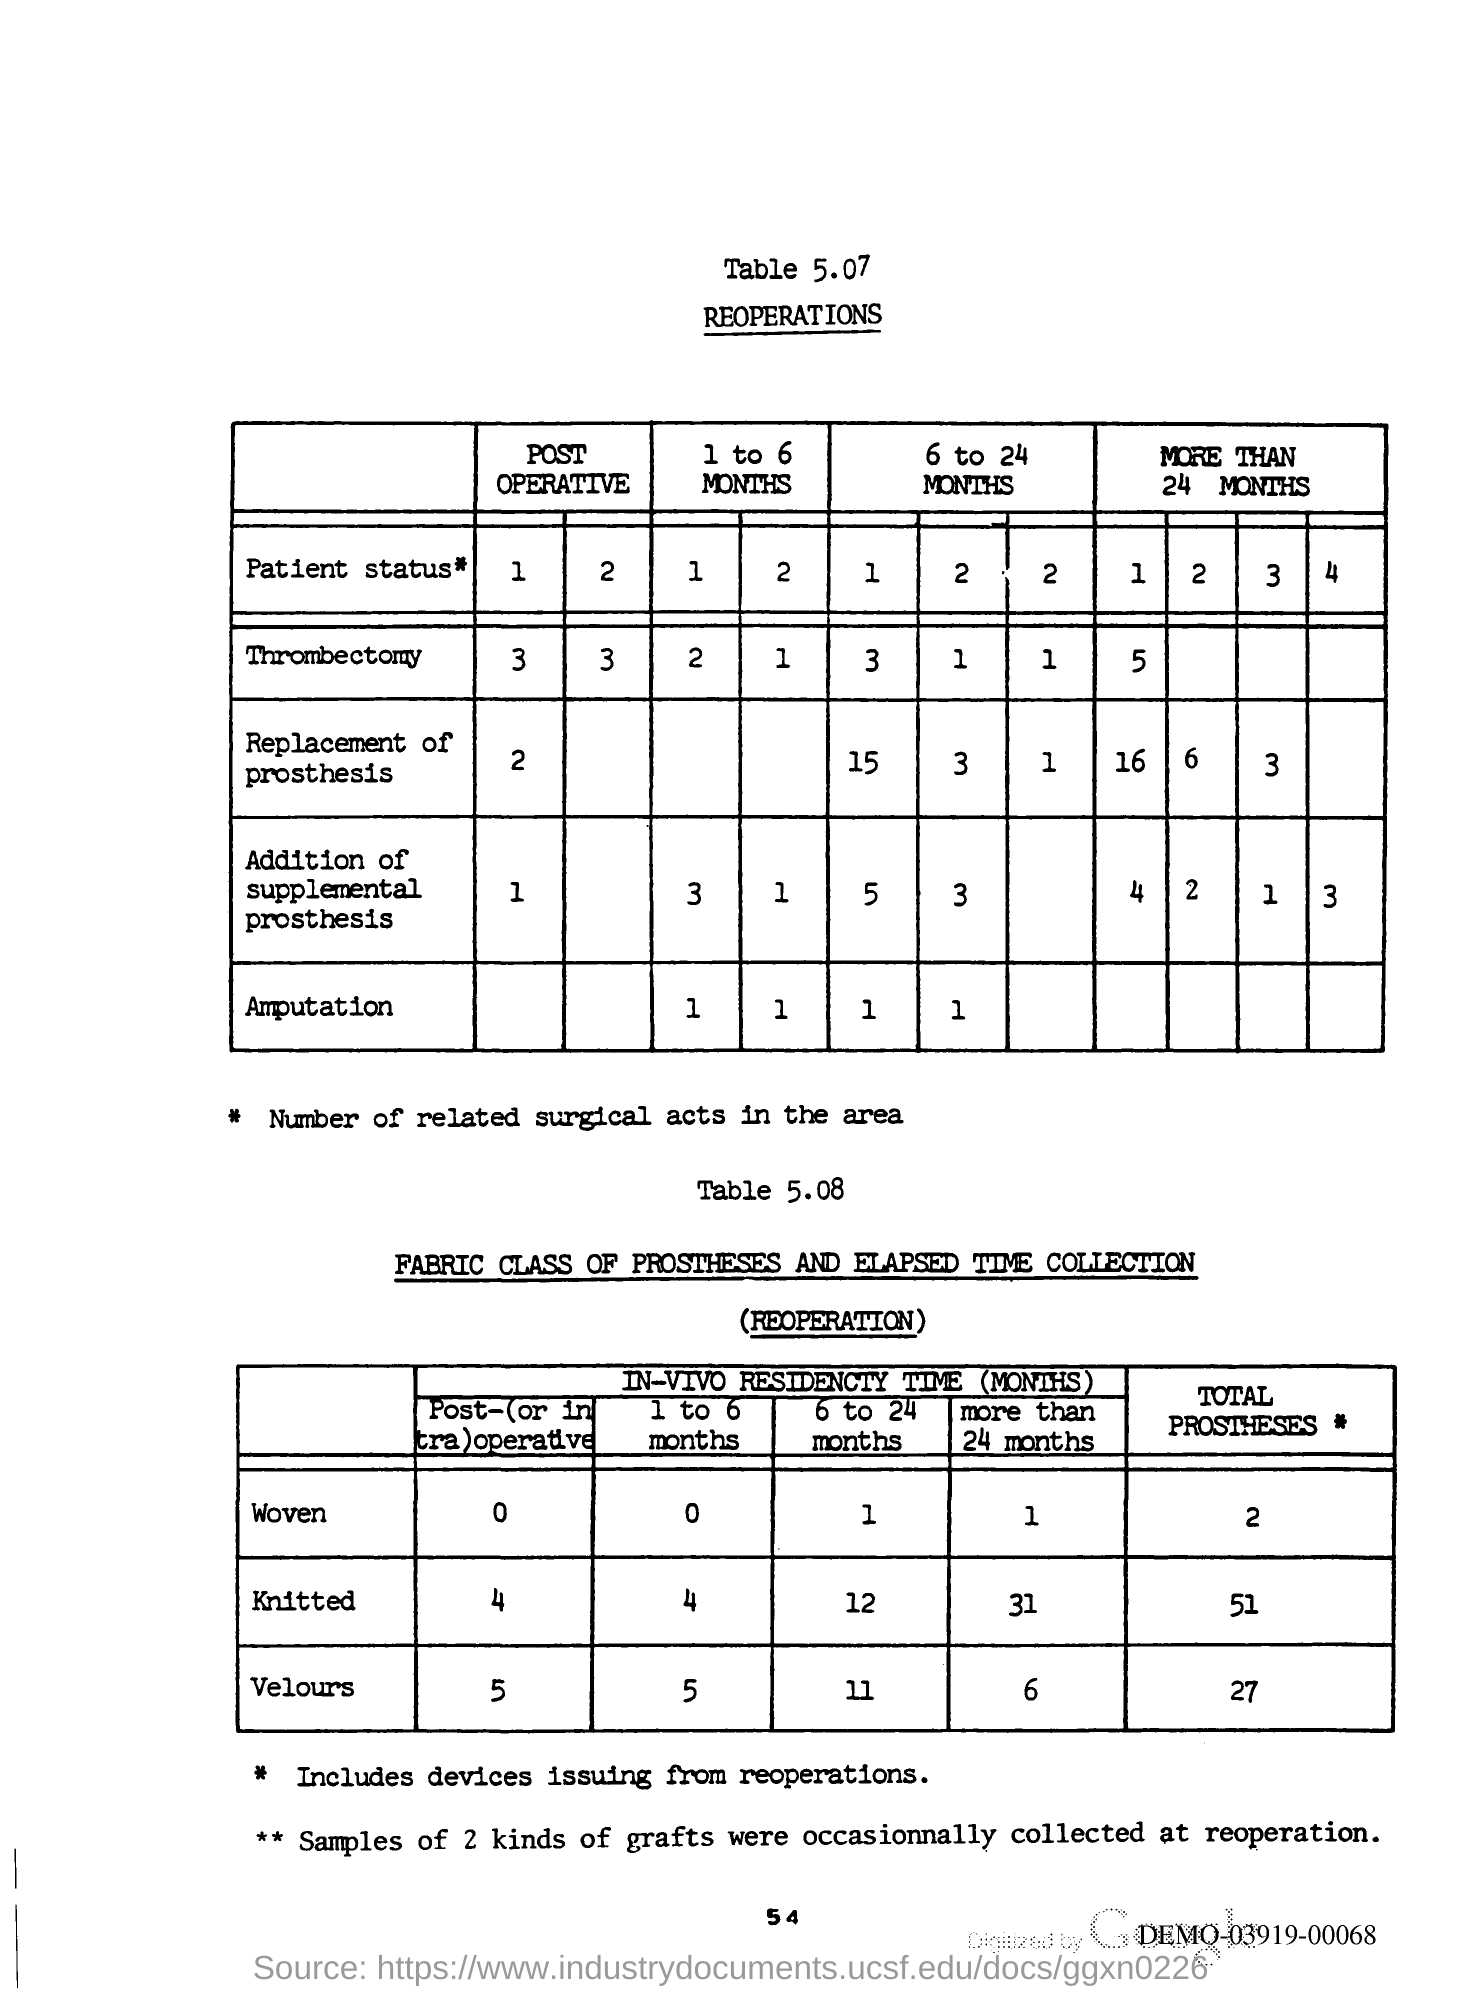What is the Page Number?
Provide a short and direct response. 54. 